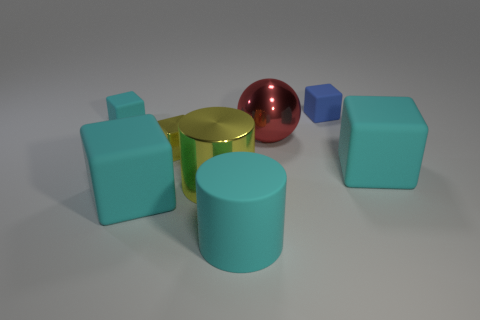What number of other things are there of the same size as the red object?
Offer a terse response. 4. Do the shiny block and the large cube that is on the right side of the red ball have the same color?
Give a very brief answer. No. What number of objects are big yellow cylinders or large red metallic things?
Ensure brevity in your answer.  2. Is there any other thing of the same color as the metallic block?
Your answer should be very brief. Yes. Are the small cyan object and the cyan cube to the right of the small blue matte object made of the same material?
Provide a succinct answer. Yes. The big cyan thing in front of the large cyan rubber cube that is on the left side of the small blue thing is what shape?
Give a very brief answer. Cylinder. There is a matte object that is behind the small metallic thing and on the right side of the large yellow cylinder; what is its shape?
Offer a very short reply. Cube. What number of objects are metal things or small cubes behind the red object?
Your answer should be very brief. 5. There is a small yellow object that is the same shape as the small cyan thing; what is it made of?
Your answer should be compact. Metal. Is there anything else that is the same material as the large cyan cylinder?
Your answer should be very brief. Yes. 